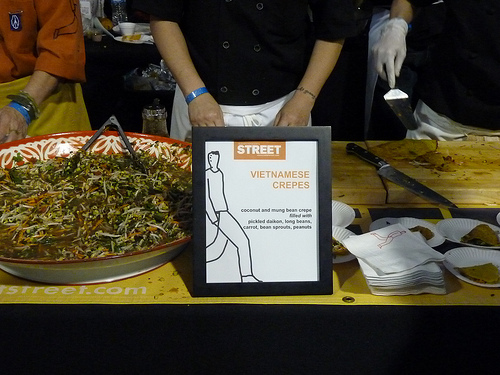<image>
Is the watch above the bowl? No. The watch is not positioned above the bowl. The vertical arrangement shows a different relationship. 